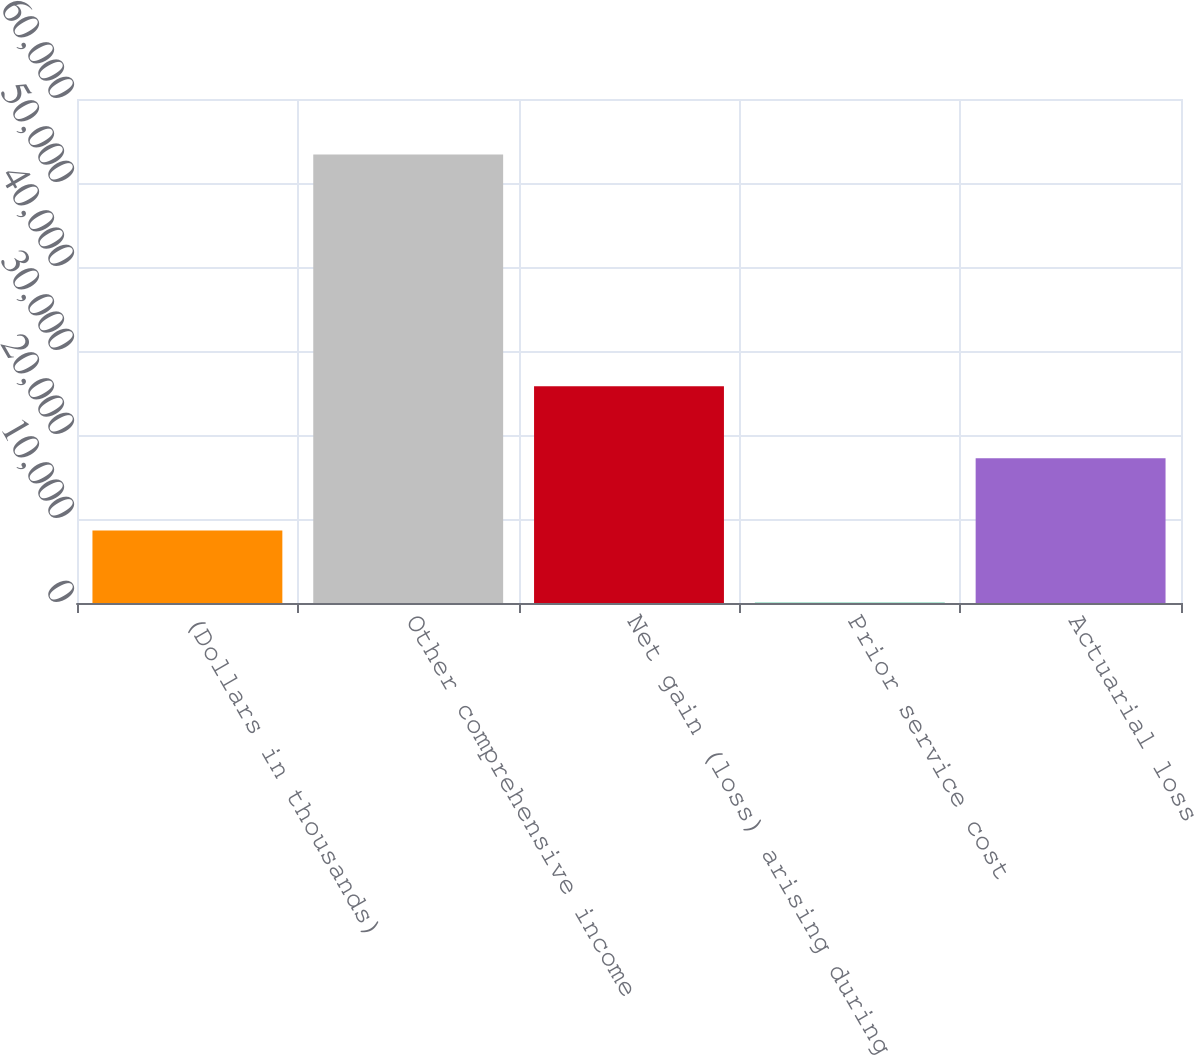Convert chart to OTSL. <chart><loc_0><loc_0><loc_500><loc_500><bar_chart><fcel>(Dollars in thousands)<fcel>Other comprehensive income<fcel>Net gain (loss) arising during<fcel>Prior service cost<fcel>Actuarial loss<nl><fcel>8638<fcel>53387<fcel>25816<fcel>49<fcel>17227<nl></chart> 